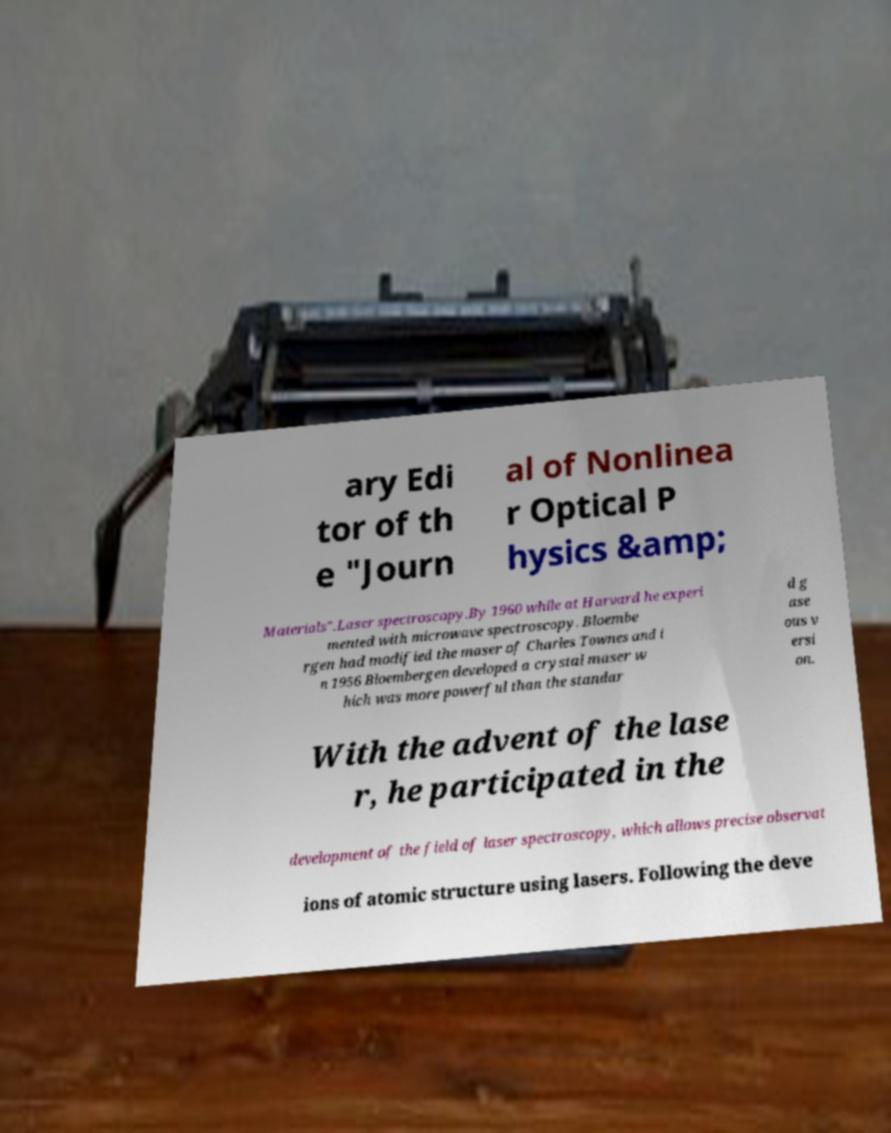For documentation purposes, I need the text within this image transcribed. Could you provide that? ary Edi tor of th e "Journ al of Nonlinea r Optical P hysics &amp; Materials".Laser spectroscopy.By 1960 while at Harvard he experi mented with microwave spectroscopy. Bloembe rgen had modified the maser of Charles Townes and i n 1956 Bloembergen developed a crystal maser w hich was more powerful than the standar d g ase ous v ersi on. With the advent of the lase r, he participated in the development of the field of laser spectroscopy, which allows precise observat ions of atomic structure using lasers. Following the deve 